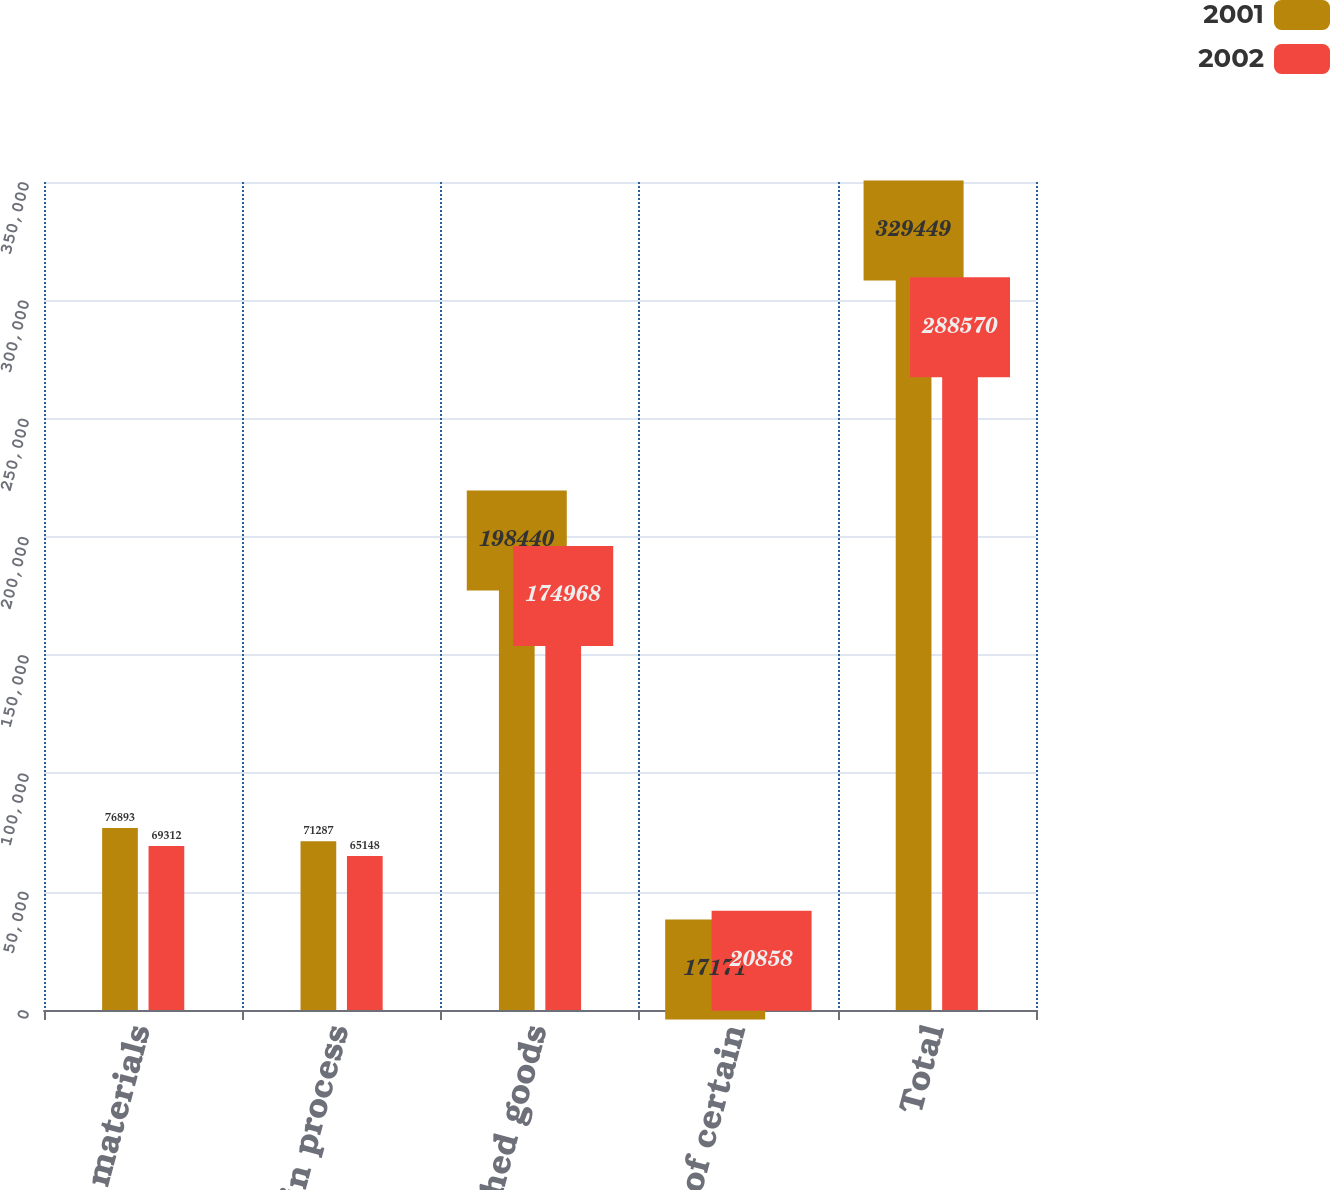Convert chart to OTSL. <chart><loc_0><loc_0><loc_500><loc_500><stacked_bar_chart><ecel><fcel>Raw materials<fcel>Work in process<fcel>Finished goods<fcel>Reduction of certain<fcel>Total<nl><fcel>2001<fcel>76893<fcel>71287<fcel>198440<fcel>17171<fcel>329449<nl><fcel>2002<fcel>69312<fcel>65148<fcel>174968<fcel>20858<fcel>288570<nl></chart> 